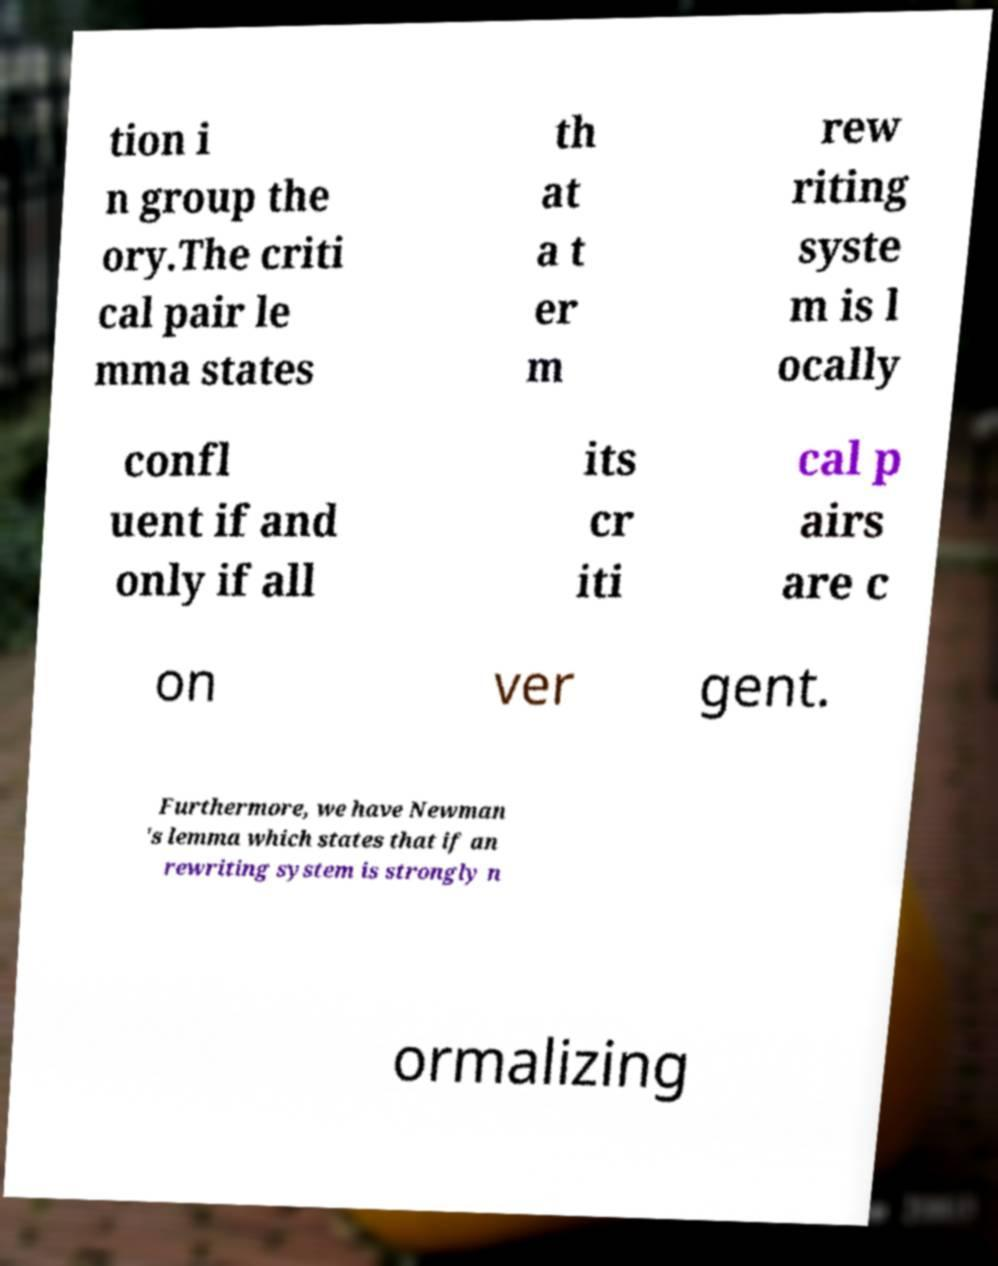There's text embedded in this image that I need extracted. Can you transcribe it verbatim? tion i n group the ory.The criti cal pair le mma states th at a t er m rew riting syste m is l ocally confl uent if and only if all its cr iti cal p airs are c on ver gent. Furthermore, we have Newman 's lemma which states that if an rewriting system is strongly n ormalizing 